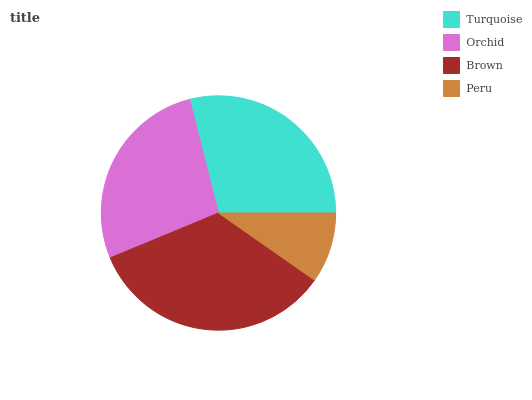Is Peru the minimum?
Answer yes or no. Yes. Is Brown the maximum?
Answer yes or no. Yes. Is Orchid the minimum?
Answer yes or no. No. Is Orchid the maximum?
Answer yes or no. No. Is Turquoise greater than Orchid?
Answer yes or no. Yes. Is Orchid less than Turquoise?
Answer yes or no. Yes. Is Orchid greater than Turquoise?
Answer yes or no. No. Is Turquoise less than Orchid?
Answer yes or no. No. Is Turquoise the high median?
Answer yes or no. Yes. Is Orchid the low median?
Answer yes or no. Yes. Is Peru the high median?
Answer yes or no. No. Is Brown the low median?
Answer yes or no. No. 